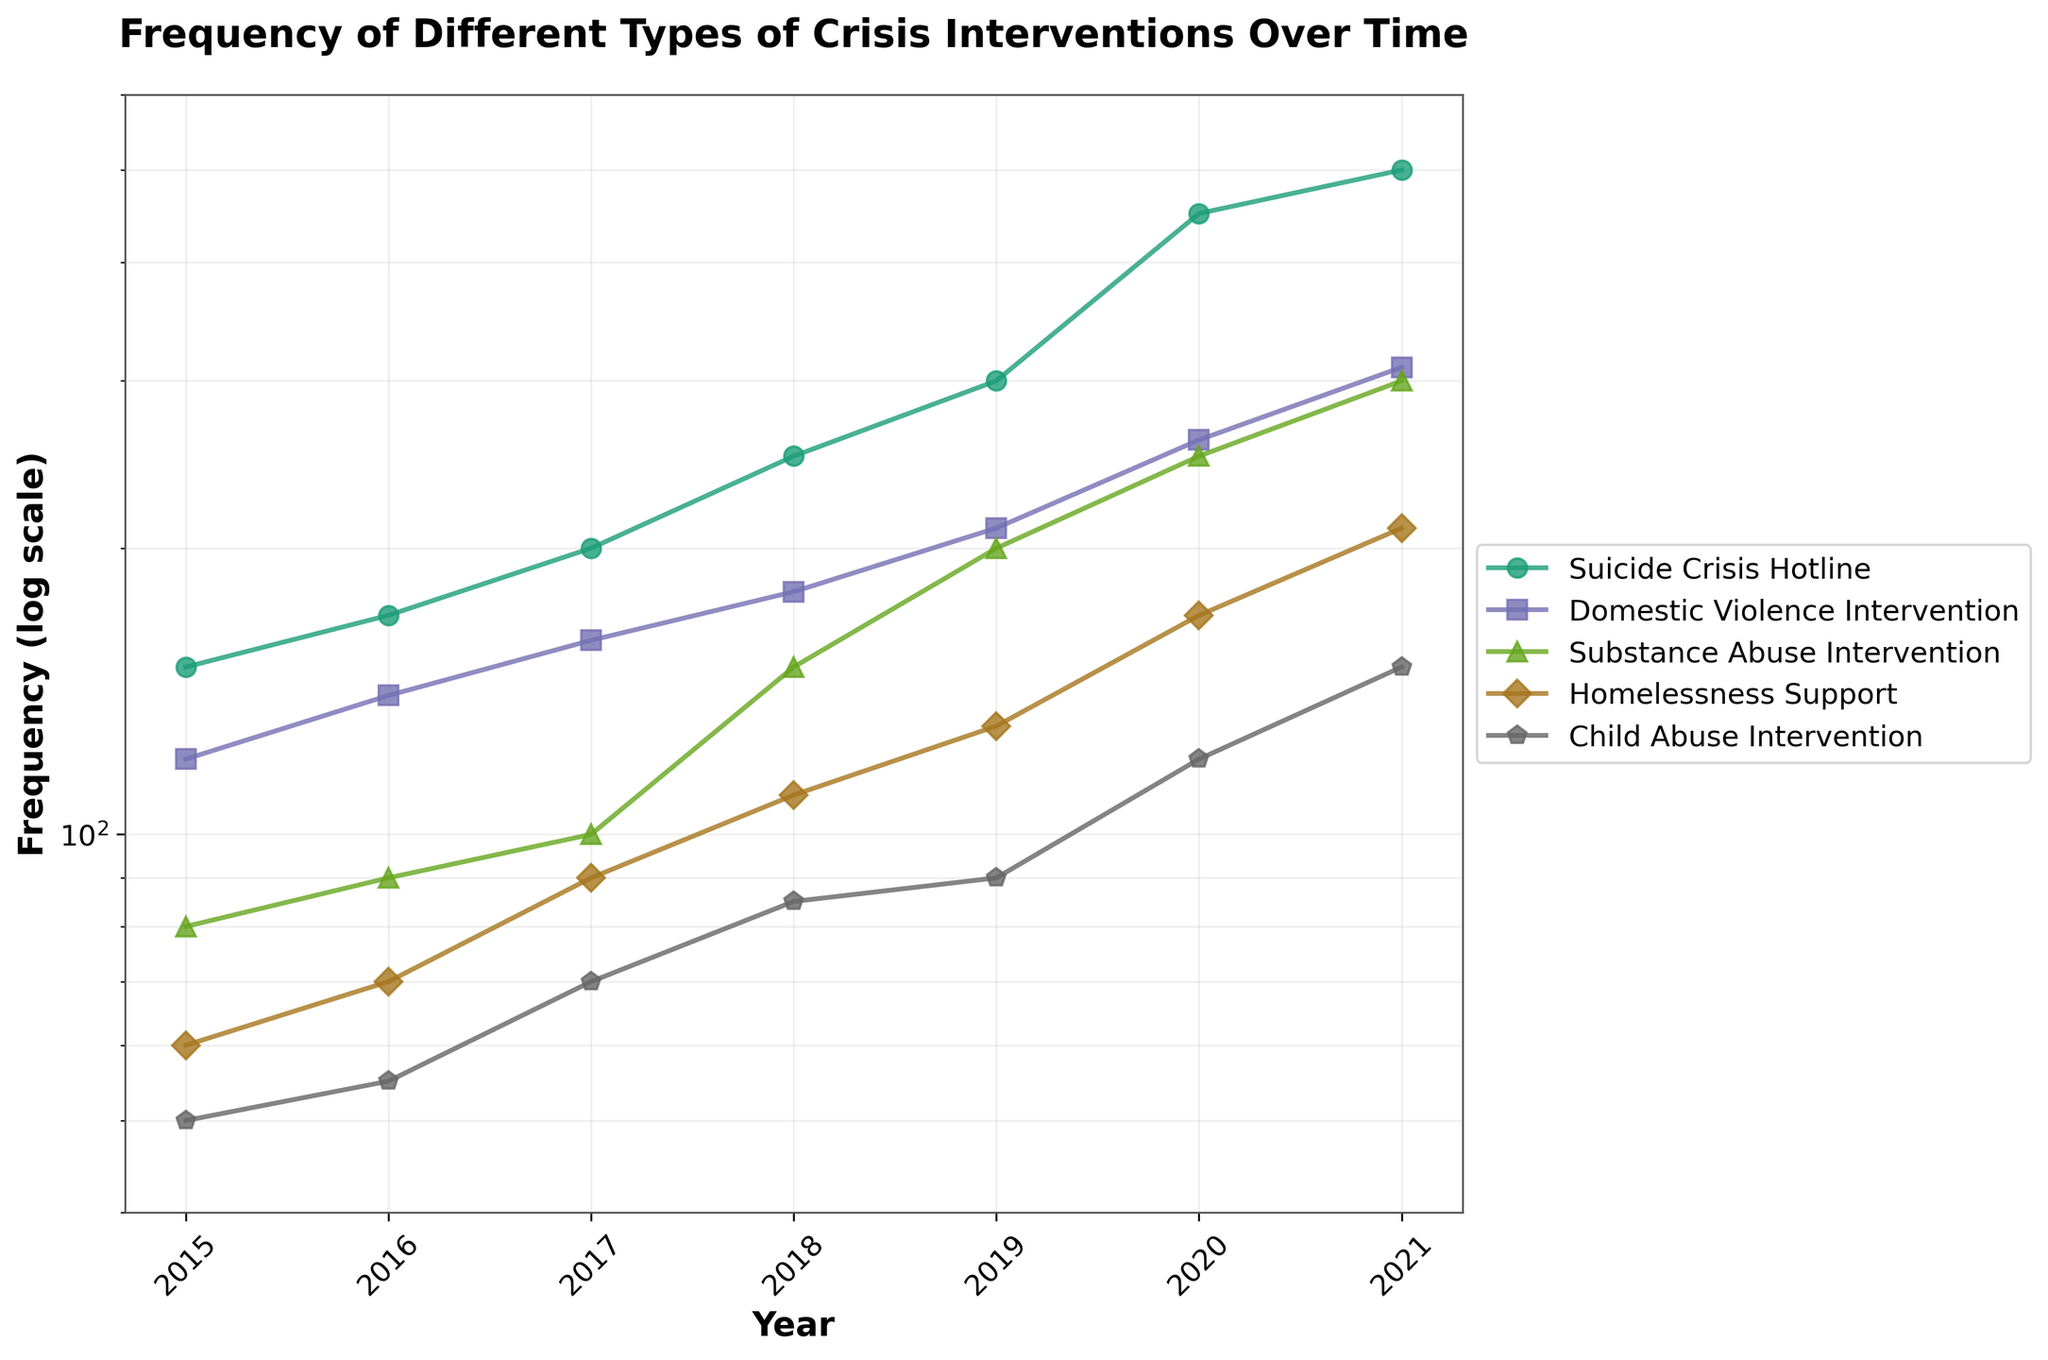What is the title of the figure? The title of the figure is prominently displayed at the top of the plot. It reads "Frequency of Different Types of Crisis Interventions Over Time," providing a clear overview of what the plot represents.
Answer: Frequency of Different Types of Crisis Interventions Over Time Which type of crisis intervention has the highest frequency in 2021? By observing the plot, you can see that each crisis intervention type is represented by a different colored line with markers. The line representing the "Suicide Crisis Hotline" has the highest value in 2021.
Answer: Suicide Crisis Hotline How many different types of crisis interventions are shown in this figure? Each different type of crisis intervention is labeled with a unique line and color. Counting the lines and checking the legend confirms there are five types.
Answer: Five What is the range of the frequency axis in this figure? The y-axis of the plot, which uses a logarithmic scale, ranges from 40 to 600, as labeled on the axis.
Answer: 40 to 600 Did the frequency of "Homelessness Support" increase or decrease over the years 2015 to 2021? The line for "Homelessness Support" shows a clear upward trend from 2015 to 2021, indicating an increase in frequency.
Answer: Increase Compare the frequency trends for "Domestic Violence Intervention" and "Substance Abuse Intervention" between 2015 and 2021. Which one had a higher rate of increase? By comparing the slopes of the lines, "Substance Abuse Intervention" shows a steeper increase from 80 in 2015 to 300 in 2021, while "Domestic Violence Intervention" increased from 120 to 310. The former had a higher rate of increase.
Answer: Substance Abuse Intervention Which crisis intervention had the least frequency in 2015? By looking at the data points for the year 2015, we see that "Child Abuse Intervention" has the lowest value at 50.
Answer: Child Abuse Intervention How does the frequency of "Child Abuse Intervention" in 2020 compare to "Homelessness Support" in the same year? Observing the points for these two types in 2020, you see that "Child Abuse Intervention" has a frequency of 120, whereas "Homelessness Support" has a frequency of 170.
Answer: Child Abuse Intervention is lower What is the average frequency of "Suicide Crisis Hotline" interventions from 2015 to 2021? Summing up the values of "Suicide Crisis Hotline" from 2015 to 2021 (150 + 170 + 200 + 250 + 300 + 450 + 500) and then dividing by the number of years (7) gives the average. The sum is 2020, so the average is 2020 / 7 = 288.57.
Answer: 288.57 Which types of crisis interventions show exponential-like growth trends? Using the log scale y-axis efficiently shows exponential growth as a straight line trend. Both "Suicide Crisis Hotline" and "Substance Abuse Intervention" display exponential-like growth with their steep increasing lines.
Answer: Suicide Crisis Hotline, Substance Abuse Intervention 